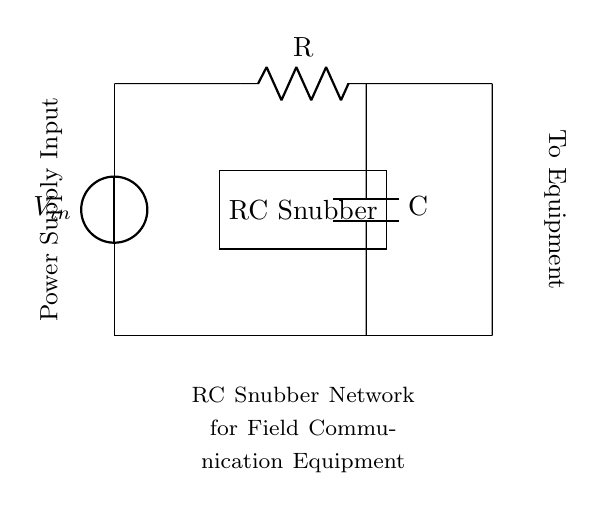What type of components are shown in the circuit? The circuit contains a resistor (R) and a capacitor (C) connected in series, forming an RC snubber network. These components are visible in the diagram, indicating their role in managing voltage spikes.
Answer: Resistor and Capacitor What is the function of the RC snubber network? The RC snubber network is designed to suppress voltage spikes and transients, protecting the power supply and connected equipment from damage. Its function is implied in the labeling of the circuit diagram, which indicates that it is specifically used for field communication equipment.
Answer: Voltage surge suppression Where is the power supply input located in the circuit? The power supply input is located at the top of the circuit diagram, connected to a voltage source (V in). The illustration shows a vertical connection leading into the resistor.
Answer: Top of the circuit What happens to excess voltage in this RC snubber network? In the RC snubber network, excess voltage is absorbed by the capacitor, which charges up and helps to reduce the voltage spike that could affect the components connected downstream. The combination of the resistor and capacitor works to dissipate energy safely.
Answer: Voltage is absorbed How do the resistor and capacitor interact during a voltage spike? During a voltage spike, the capacitor responds quickly by charging up, which reduces the rate of voltage increase. The resistor then dissipates the energy in the form of heat, slowing the voltage rise and stabilizing the power supply to protect the downstream equipment. This interaction is fundamental to the operation of RC snubber circuits.
Answer: The capacitor absorbs, the resistor dissipates What is the role of the resistor (R) in this circuit? The resistor serves to limit the current and provide damping in the snubber circuit. This helps to prevent excessive charging of the capacitor and allows for controlled discharge, which mitigates potential damage to the power supply unit and connected equipment.
Answer: Current limiting and damping 